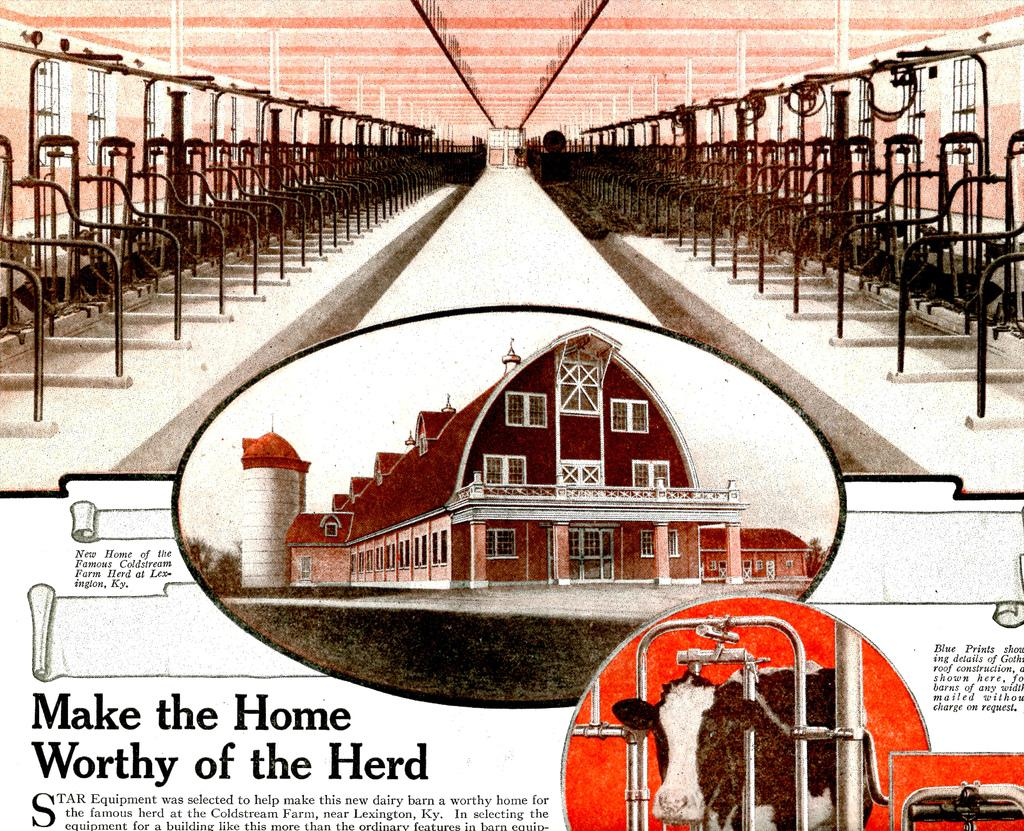<image>
Relay a brief, clear account of the picture shown. A poster that says Make the Home Worthy of the Herd. 